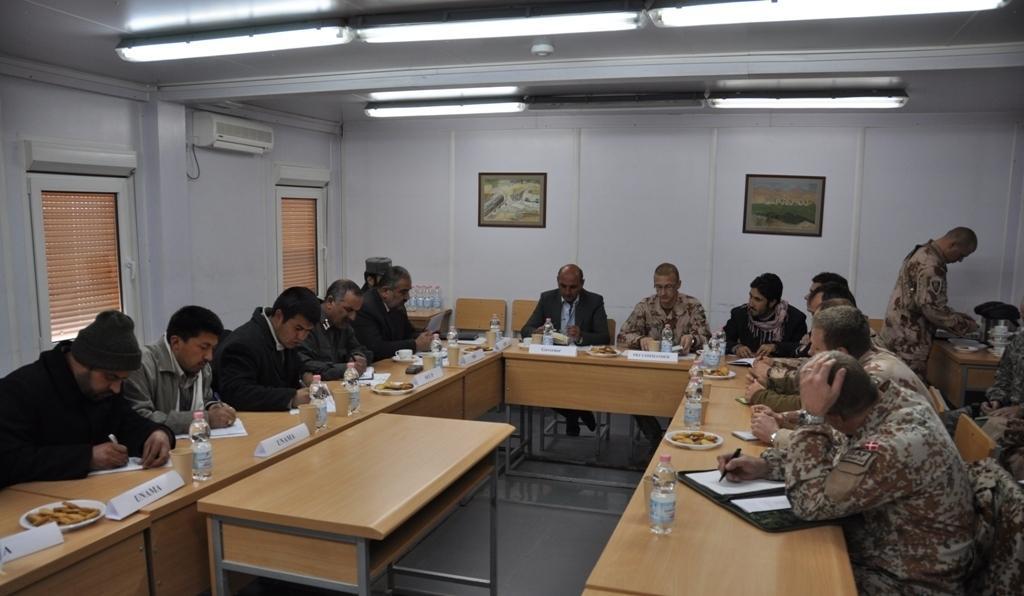In one or two sentences, can you explain what this image depicts? A group of men are discussing in a meeting sitting at a table. 